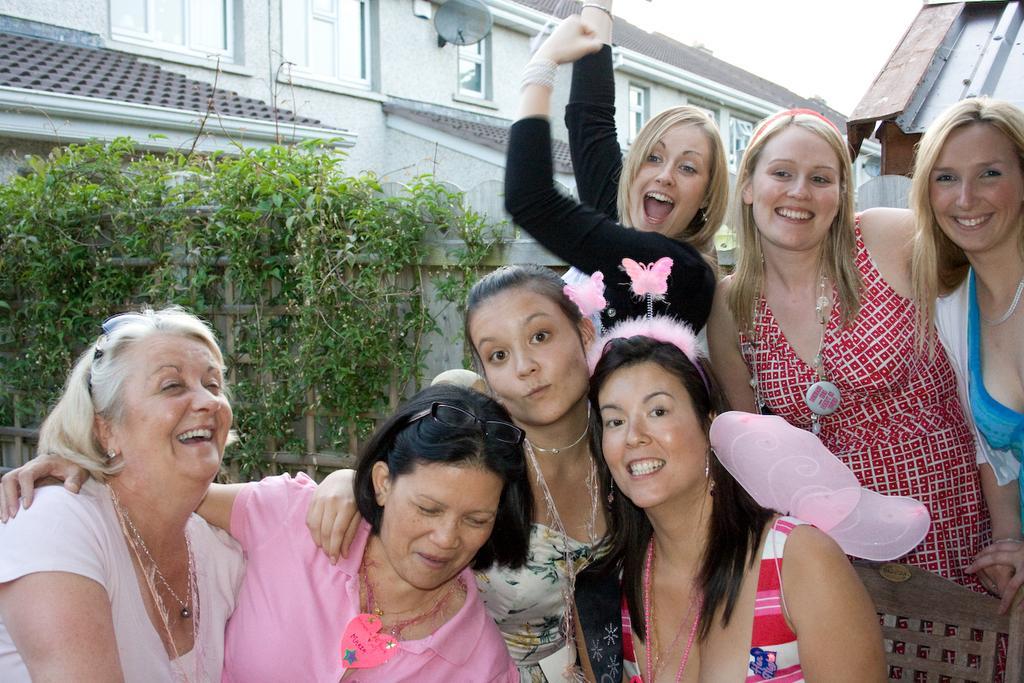In one or two sentences, can you explain what this image depicts? In the center of the image we can see a group of women. In the background we can see plants, wall, building, dish and a sky. 